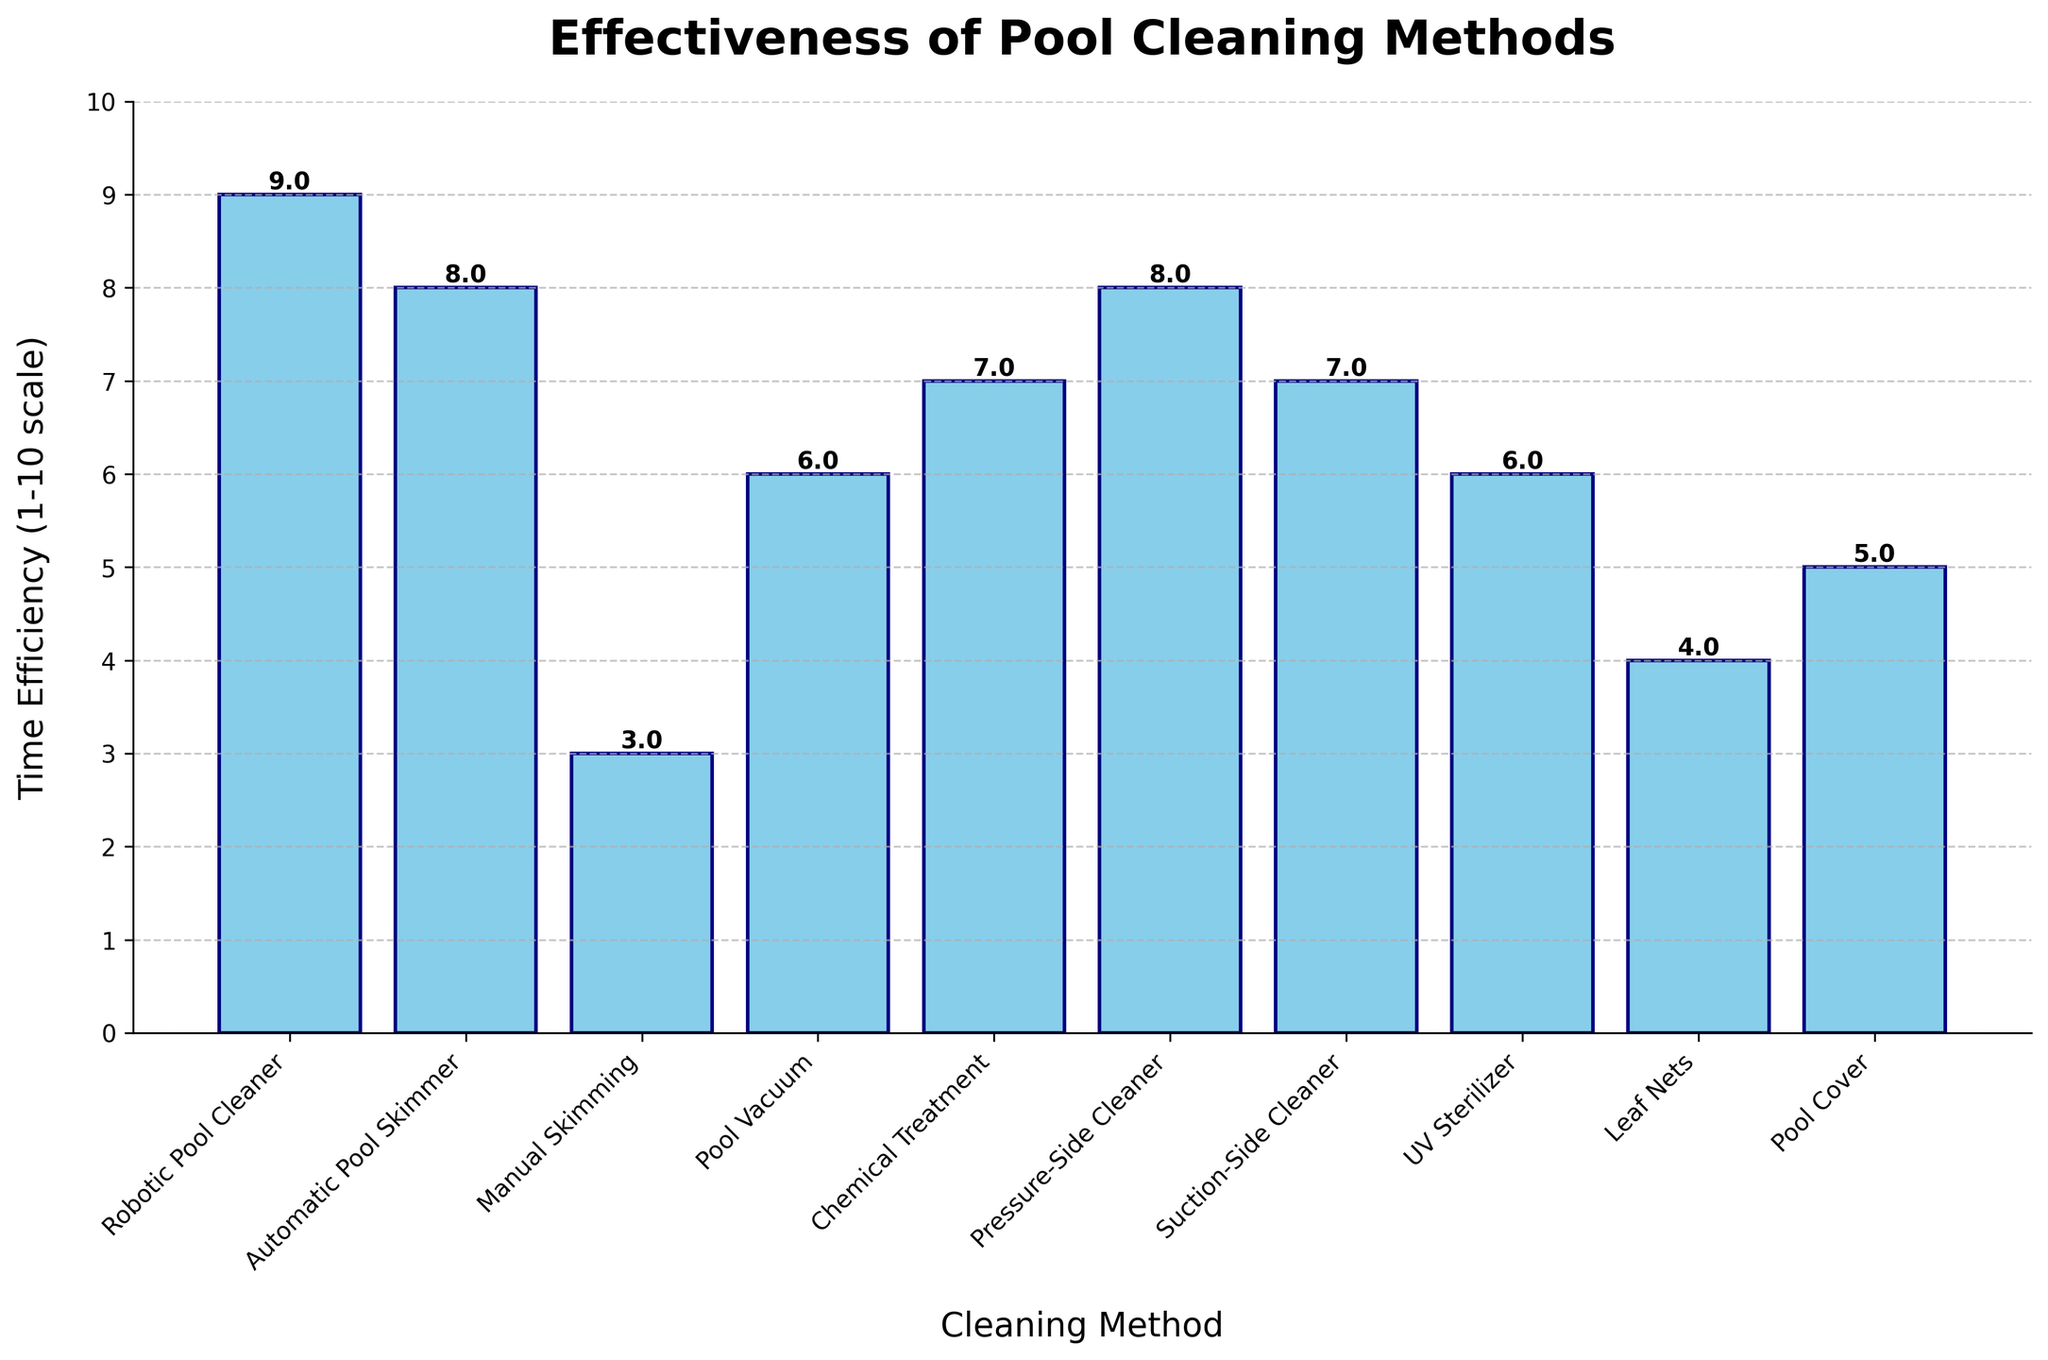Which pool cleaning method has the highest time efficiency rating? Look for the tallest bar in the chart, which corresponds to the highest value. In this case, the tallest bar represents the "Robotic Pool Cleaner" with a time efficiency rating of 9.
Answer: Robotic Pool Cleaner Which two methods have the same time efficiency rating of 8? Identify the bars that reach the value of 8 on the y-axis. The bars for "Automatic Pool Skimmer" and "Pressure-Side Cleaner" both reach 8.
Answer: Automatic Pool Skimmer, Pressure-Side Cleaner What is the average time efficiency rating across all methods? Add the time efficiency ratings of all methods (9 + 8 + 3 + 6 + 7 + 8 + 7 + 6 + 4 + 5) which equals 63, then divide by the number of methods (10). The average is 63/10 = 6.3.
Answer: 6.3 Which method is less time efficient, Manual Skimming or Pool Cover? Compare the heights of the bars for "Manual Skimming" and "Pool Cover". The bar for "Manual Skimming" is shorter, indicating a lower value (3 compared to 5).
Answer: Manual Skimming What is the difference in time efficiency rating between the most and least effective methods? Identify the highest and lowest values: "Robotic Pool Cleaner" (9) and "Manual Skimming" (3). Subtract the lowest value from the highest (9 - 3).
Answer: 6 How many methods have a time efficiency rating of 6 or higher? Count the bars that reach the value of 6 or higher. The methods are "Robotic Pool Cleaner", "Automatic Pool Skimmer", "Pool Vacuum", "Chemical Treatment", "Pressure-Side Cleaner", "Suction-Side Cleaner", and "UV Sterilizer" (7 bars in total).
Answer: 7 Which method is positioned exactly in the middle when sorted by time efficiency? List all methods by their ratings (3, 4, 5, 6, 6, 7, 7, 8, 8, 9) and find the middle value(s). "Pool Vacuum" and "UV Sterilizer" both have a rating of 6 and are positioned in the middle of the list.
Answer: Pool Vacuum, UV Sterilizer What is the combined time efficiency rating of all chemical and mechanical methods? Identify and sum the ratings of chemical (Chemical Treatment = 7) and mechanical (Robotic Pool Cleaner = 9, Automatic Pool Skimmer = 8, Manual Skimming = 3, Pool Vacuum = 6, Pressure-Side Cleaner = 8, Suction-Side Cleaner = 7) methods, giving a total of 9 + 8 + 3 + 6 + 8 + 7 + 7, which equals 48.
Answer: 48 If you were to replace the least efficient method with a new method rated at 10, what would the new average efficiency be? Replace the lowest rating (3 for "Manual Skimming") with 10, then recalculate the average: (9 + 8 + 10 + 6 + 7 + 8 + 7 + 6 + 4 + 5) = 70, and divide by the number of methods (10). The new average is 70/10 = 7.
Answer: 7 